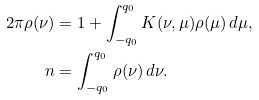<formula> <loc_0><loc_0><loc_500><loc_500>2 \pi \rho ( \nu ) & = 1 + \int _ { - q _ { 0 } } ^ { q _ { 0 } } K ( \nu , \mu ) \rho ( \mu ) \, d \mu , \\ n & = \int _ { - q _ { 0 } } ^ { q _ { 0 } } \rho ( \nu ) \, d \nu .</formula> 